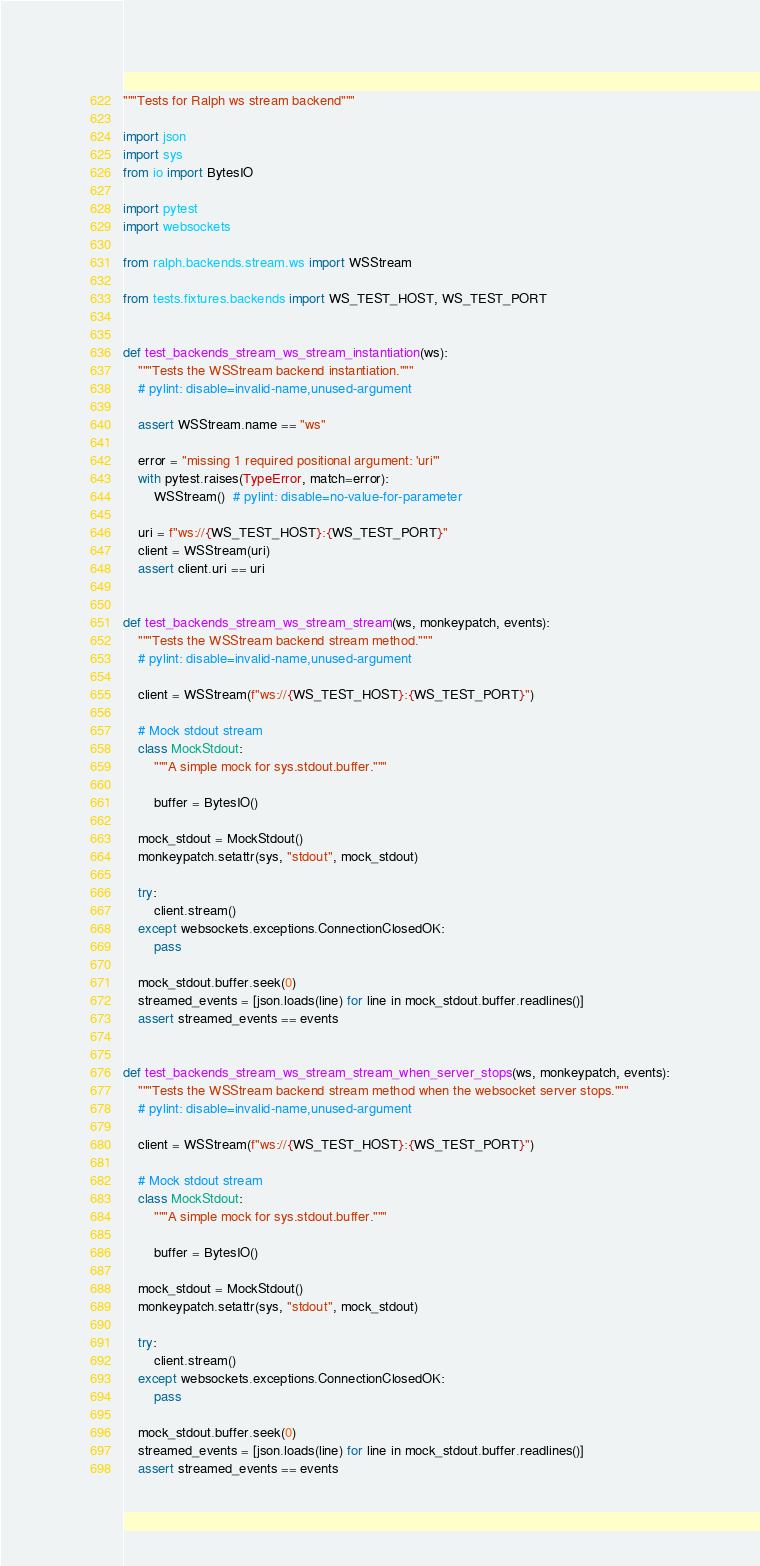Convert code to text. <code><loc_0><loc_0><loc_500><loc_500><_Python_>"""Tests for Ralph ws stream backend"""

import json
import sys
from io import BytesIO

import pytest
import websockets

from ralph.backends.stream.ws import WSStream

from tests.fixtures.backends import WS_TEST_HOST, WS_TEST_PORT


def test_backends_stream_ws_stream_instantiation(ws):
    """Tests the WSStream backend instantiation."""
    # pylint: disable=invalid-name,unused-argument

    assert WSStream.name == "ws"

    error = "missing 1 required positional argument: 'uri'"
    with pytest.raises(TypeError, match=error):
        WSStream()  # pylint: disable=no-value-for-parameter

    uri = f"ws://{WS_TEST_HOST}:{WS_TEST_PORT}"
    client = WSStream(uri)
    assert client.uri == uri


def test_backends_stream_ws_stream_stream(ws, monkeypatch, events):
    """Tests the WSStream backend stream method."""
    # pylint: disable=invalid-name,unused-argument

    client = WSStream(f"ws://{WS_TEST_HOST}:{WS_TEST_PORT}")

    # Mock stdout stream
    class MockStdout:
        """A simple mock for sys.stdout.buffer."""

        buffer = BytesIO()

    mock_stdout = MockStdout()
    monkeypatch.setattr(sys, "stdout", mock_stdout)

    try:
        client.stream()
    except websockets.exceptions.ConnectionClosedOK:
        pass

    mock_stdout.buffer.seek(0)
    streamed_events = [json.loads(line) for line in mock_stdout.buffer.readlines()]
    assert streamed_events == events


def test_backends_stream_ws_stream_stream_when_server_stops(ws, monkeypatch, events):
    """Tests the WSStream backend stream method when the websocket server stops."""
    # pylint: disable=invalid-name,unused-argument

    client = WSStream(f"ws://{WS_TEST_HOST}:{WS_TEST_PORT}")

    # Mock stdout stream
    class MockStdout:
        """A simple mock for sys.stdout.buffer."""

        buffer = BytesIO()

    mock_stdout = MockStdout()
    monkeypatch.setattr(sys, "stdout", mock_stdout)

    try:
        client.stream()
    except websockets.exceptions.ConnectionClosedOK:
        pass

    mock_stdout.buffer.seek(0)
    streamed_events = [json.loads(line) for line in mock_stdout.buffer.readlines()]
    assert streamed_events == events
</code> 